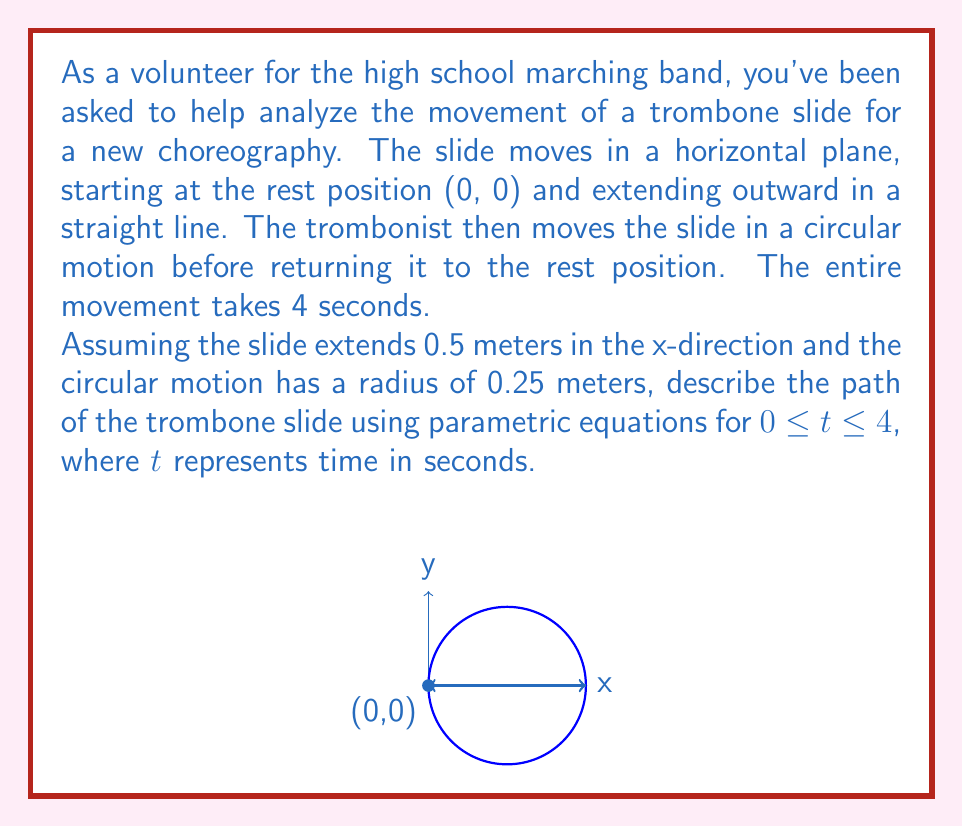What is the answer to this math problem? Let's break this problem down into three phases and define parametric equations for each:

1) Extension phase (0 ≤ t < 1):
   The slide moves linearly from (0,0) to (0.5,0)
   $x = 0.5t$, $y = 0$

2) Circular motion phase (1 ≤ t < 3):
   The slide moves in a circle with center (0.5,0) and radius 0.25
   $x = 0.5 + 0.25\cos(\pi(t-1))$
   $y = 0.25\sin(\pi(t-1))$

3) Return phase (3 ≤ t ≤ 4):
   The slide moves linearly back to (0,0)
   $x = 0.5(4-t)$, $y = 0$

Now, we can combine these into piecewise functions:

$$x(t) = \begin{cases}
0.5t & \text{if } 0 \leq t < 1 \\
0.5 + 0.25\cos(\pi(t-1)) & \text{if } 1 \leq t < 3 \\
0.5(4-t) & \text{if } 3 \leq t \leq 4
\end{cases}$$

$$y(t) = \begin{cases}
0 & \text{if } 0 \leq t < 1 \\
0.25\sin(\pi(t-1)) & \text{if } 1 \leq t < 3 \\
0 & \text{if } 3 \leq t \leq 4
\end{cases}$$

These parametric equations describe the complete motion of the trombone slide over the 4-second interval.
Answer: $x(t) = \begin{cases}
0.5t & \text{if } 0 \leq t < 1 \\
0.5 + 0.25\cos(\pi(t-1)) & \text{if } 1 \leq t < 3 \\
0.5(4-t) & \text{if } 3 \leq t \leq 4
\end{cases}$

$y(t) = \begin{cases}
0 & \text{if } 0 \leq t < 1 \\
0.25\sin(\pi(t-1)) & \text{if } 1 \leq t < 3 \\
0 & \text{if } 3 \leq t \leq 4
\end{cases}$ 